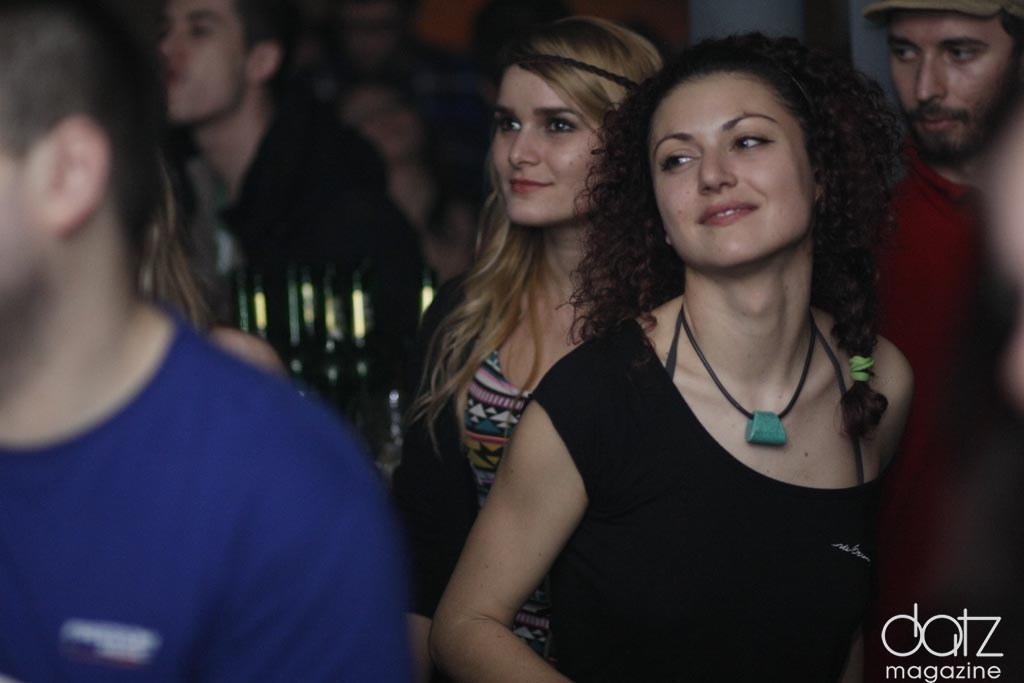Please provide a concise description of this image. This image consists of many people. To the left, the man is wearing blue T-shirt. In the front, the woman is wearing black T-shirt. In the background, there are many people. 